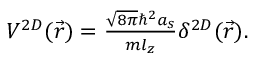Convert formula to latex. <formula><loc_0><loc_0><loc_500><loc_500>\begin{array} { r } { V ^ { 2 D } ( \vec { r } ) = \frac { \sqrt { 8 \pi } \hbar { ^ } { 2 } a _ { s } } { m l _ { z } } \delta ^ { 2 D } ( \vec { r } ) . } \end{array}</formula> 